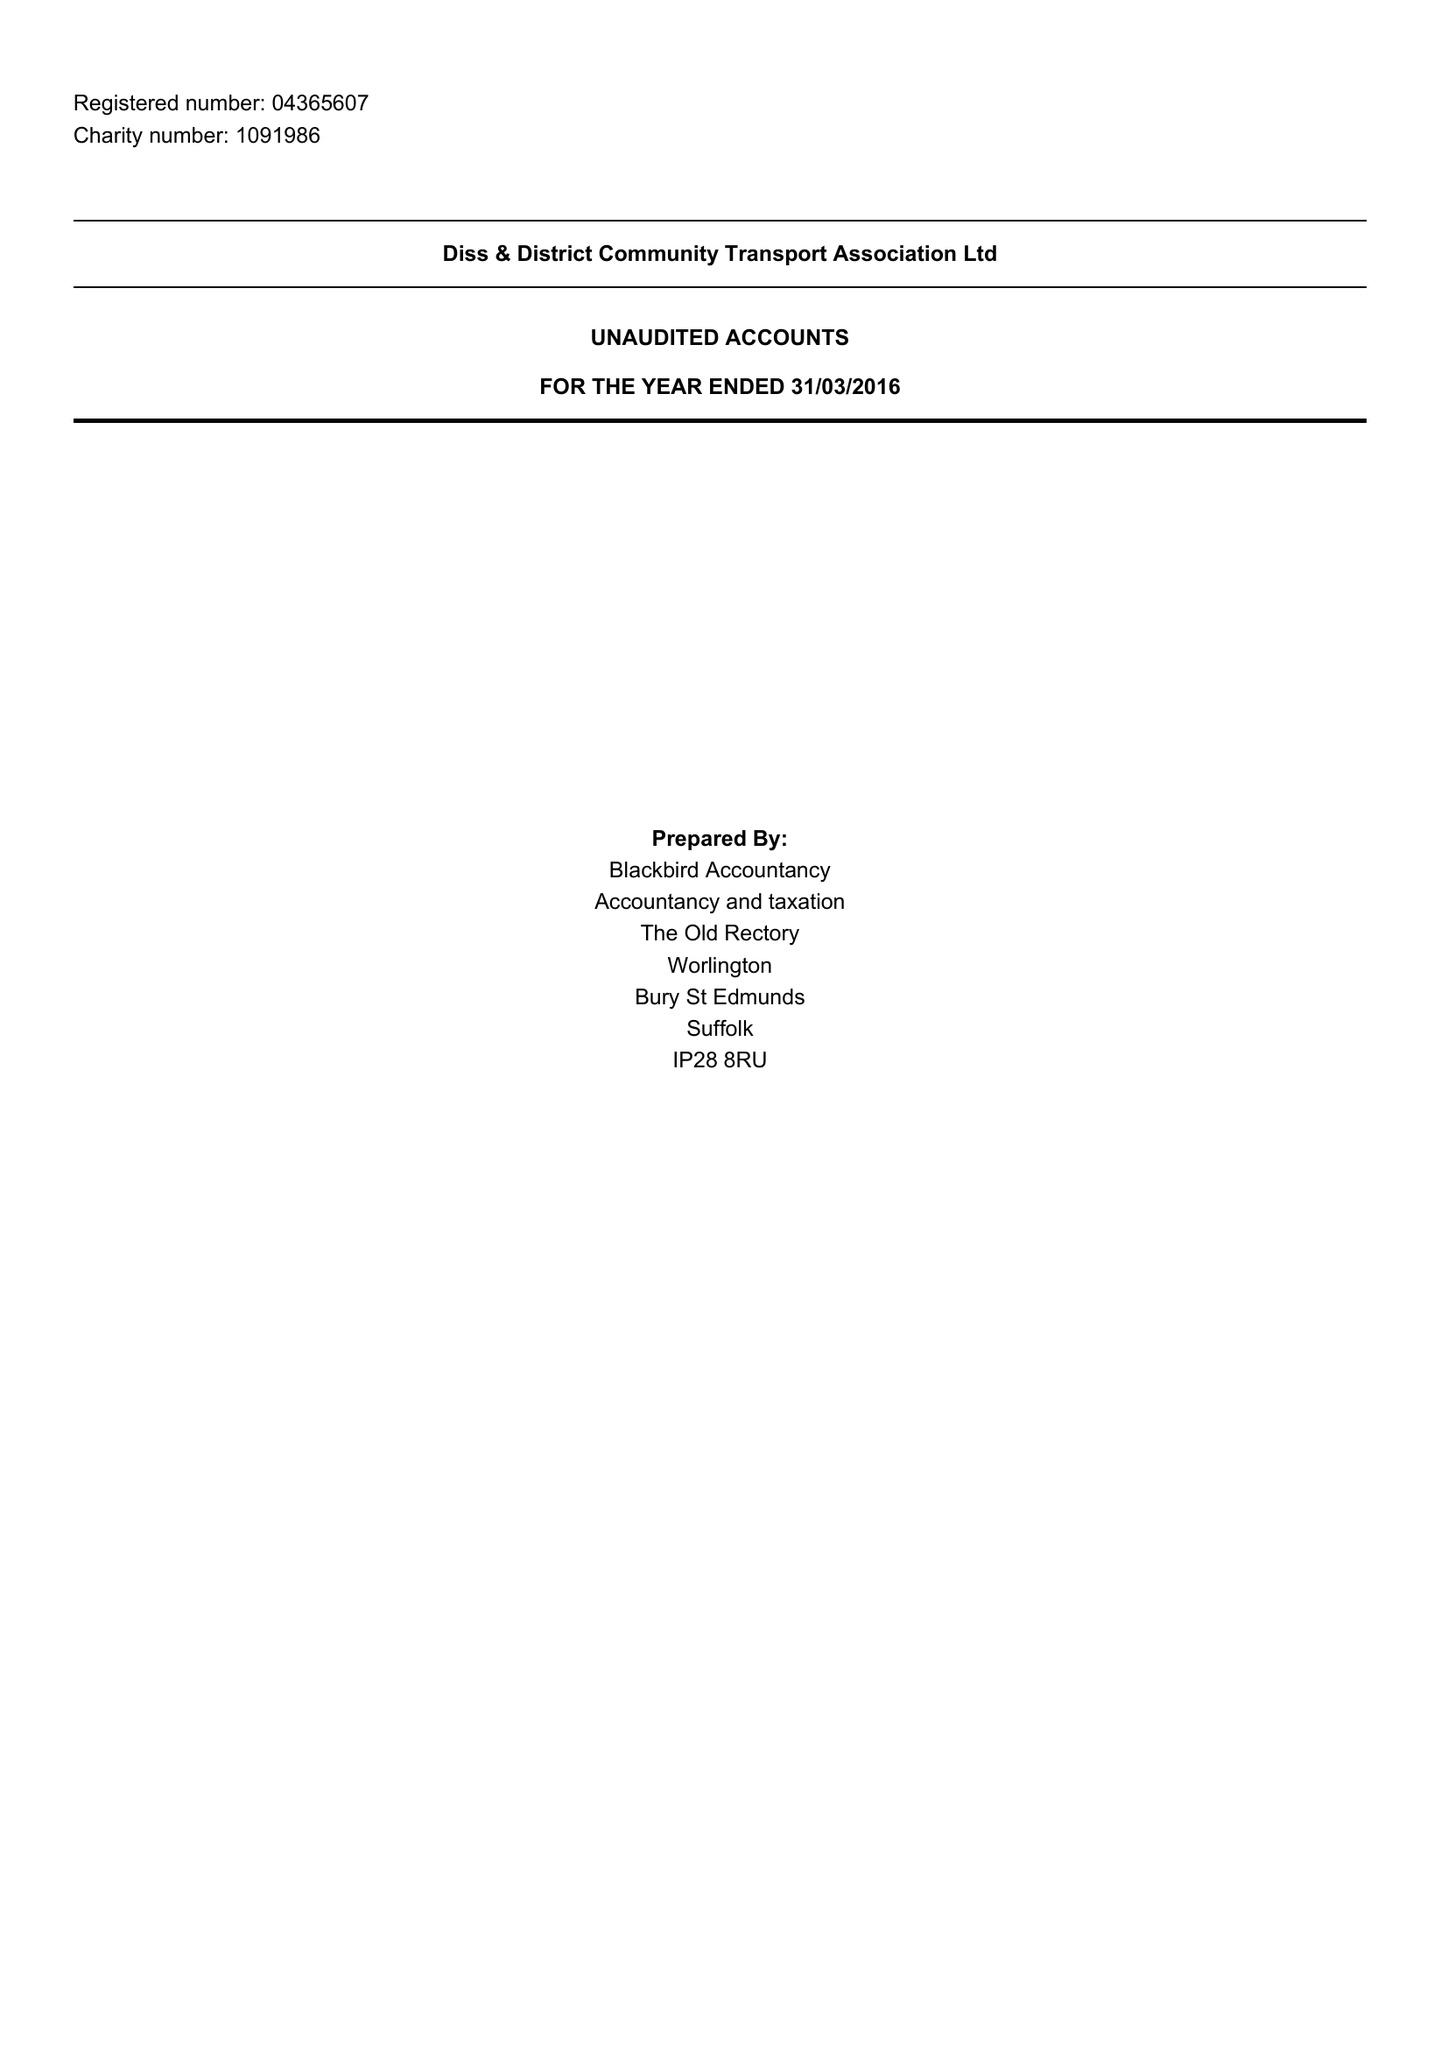What is the value for the charity_number?
Answer the question using a single word or phrase. 1091986 